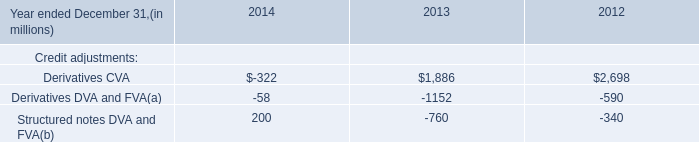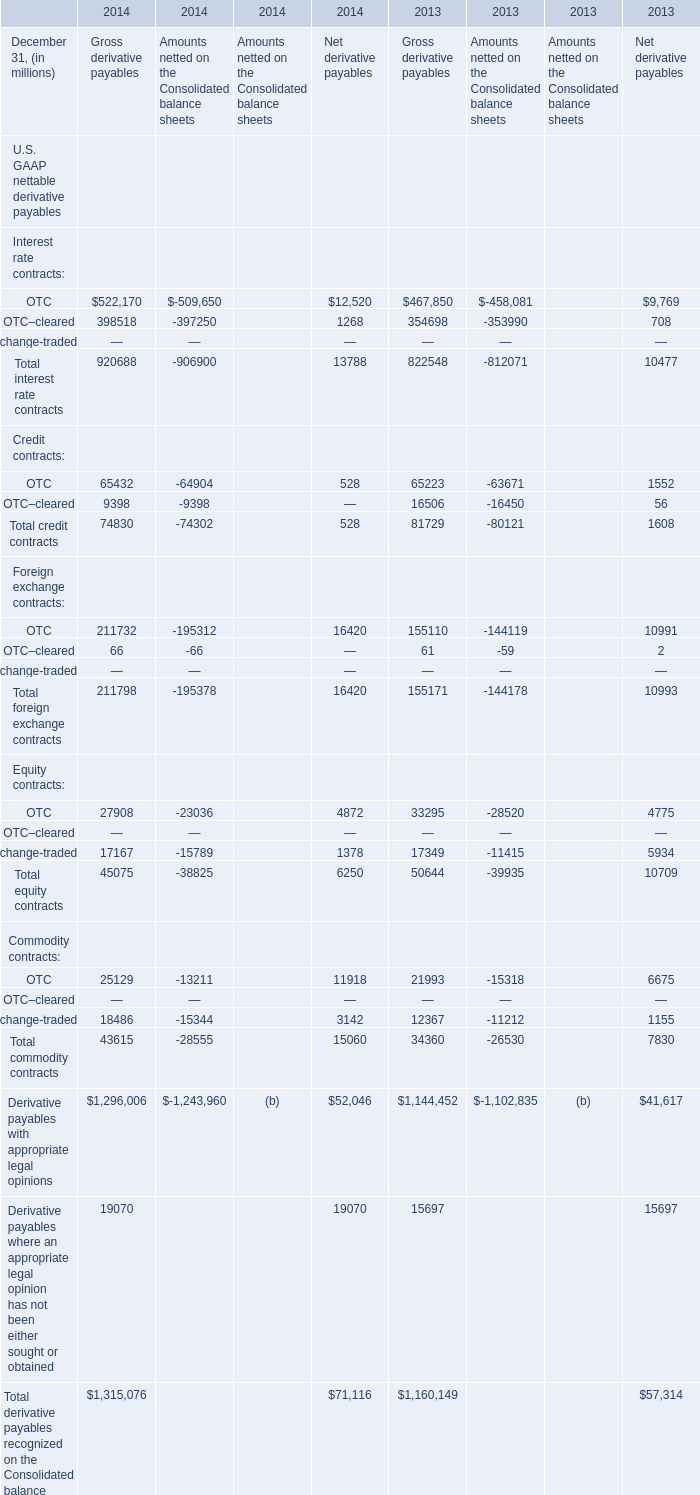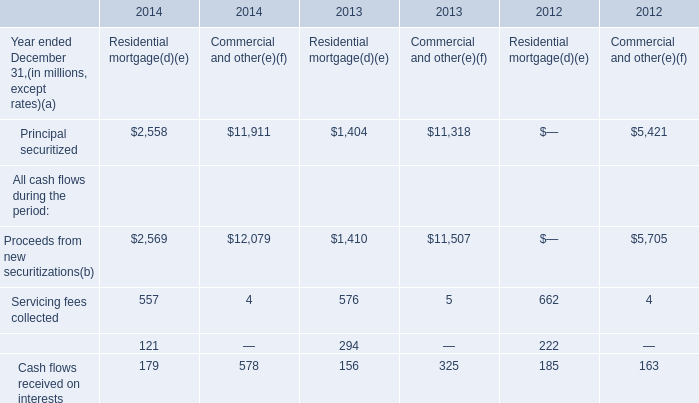What is the growing rate of OTC–cleared in the years with the least Gross derivative payables ? 
Computations: ((398518 - 354698) / 398518)
Answer: 0.10996. 